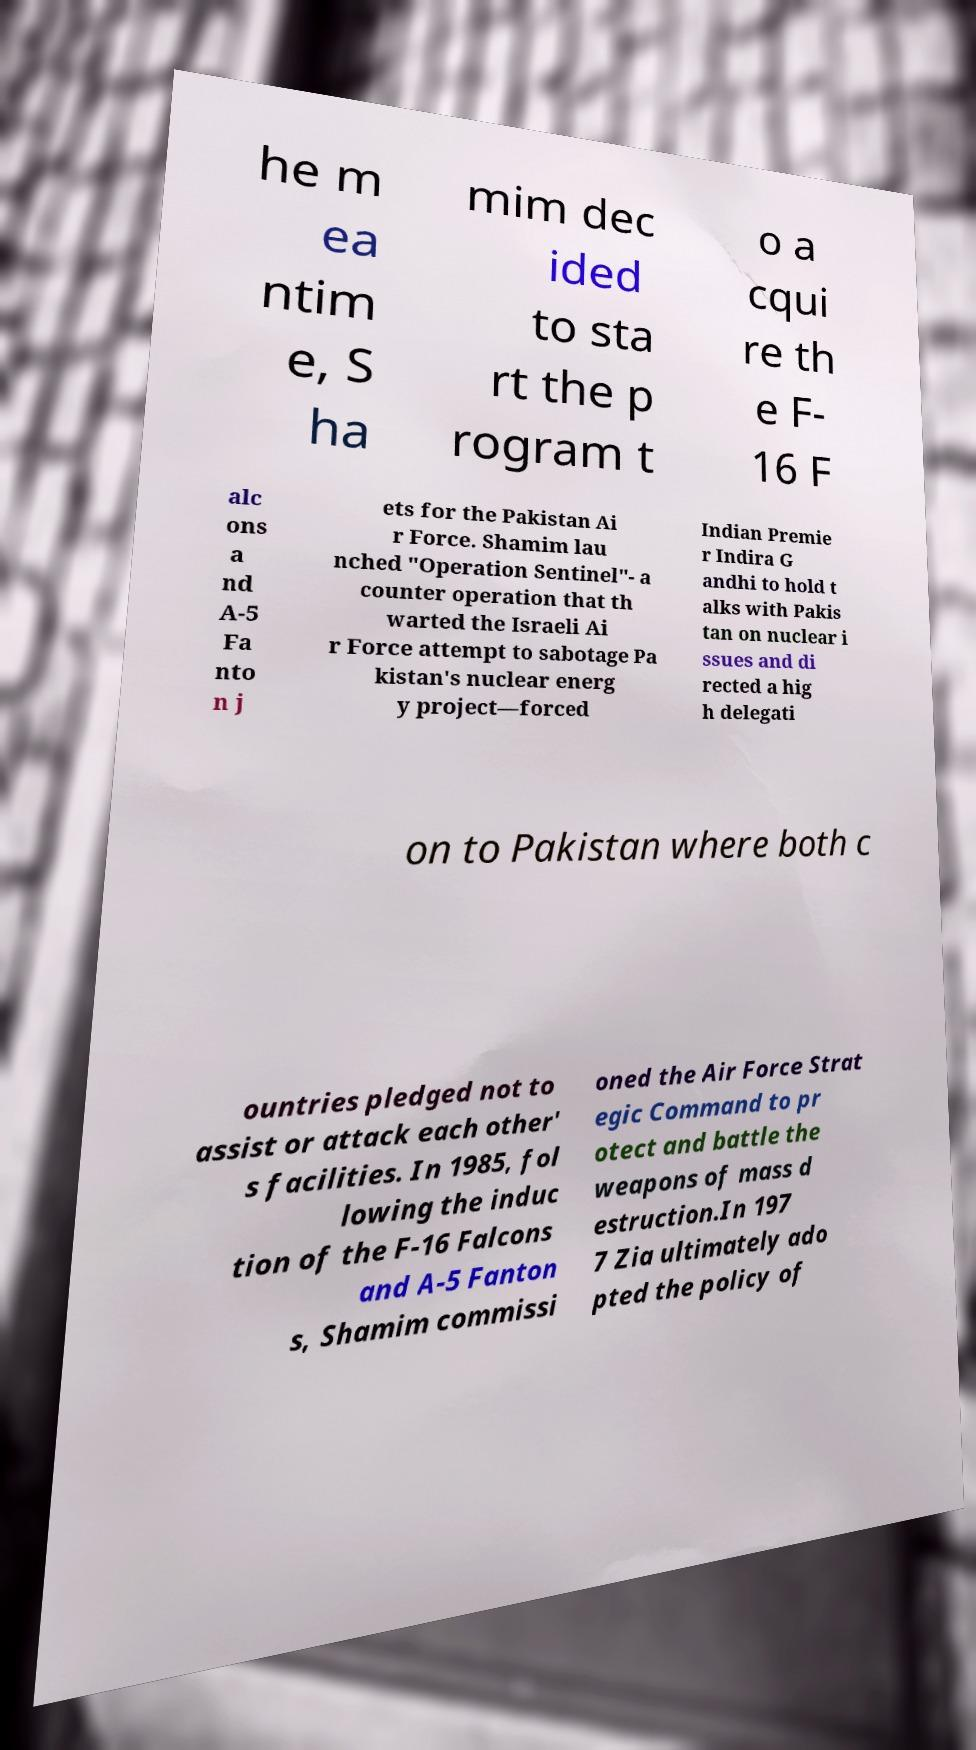What messages or text are displayed in this image? I need them in a readable, typed format. he m ea ntim e, S ha mim dec ided to sta rt the p rogram t o a cqui re th e F- 16 F alc ons a nd A-5 Fa nto n j ets for the Pakistan Ai r Force. Shamim lau nched "Operation Sentinel"- a counter operation that th warted the Israeli Ai r Force attempt to sabotage Pa kistan's nuclear energ y project—forced Indian Premie r Indira G andhi to hold t alks with Pakis tan on nuclear i ssues and di rected a hig h delegati on to Pakistan where both c ountries pledged not to assist or attack each other' s facilities. In 1985, fol lowing the induc tion of the F-16 Falcons and A-5 Fanton s, Shamim commissi oned the Air Force Strat egic Command to pr otect and battle the weapons of mass d estruction.In 197 7 Zia ultimately ado pted the policy of 